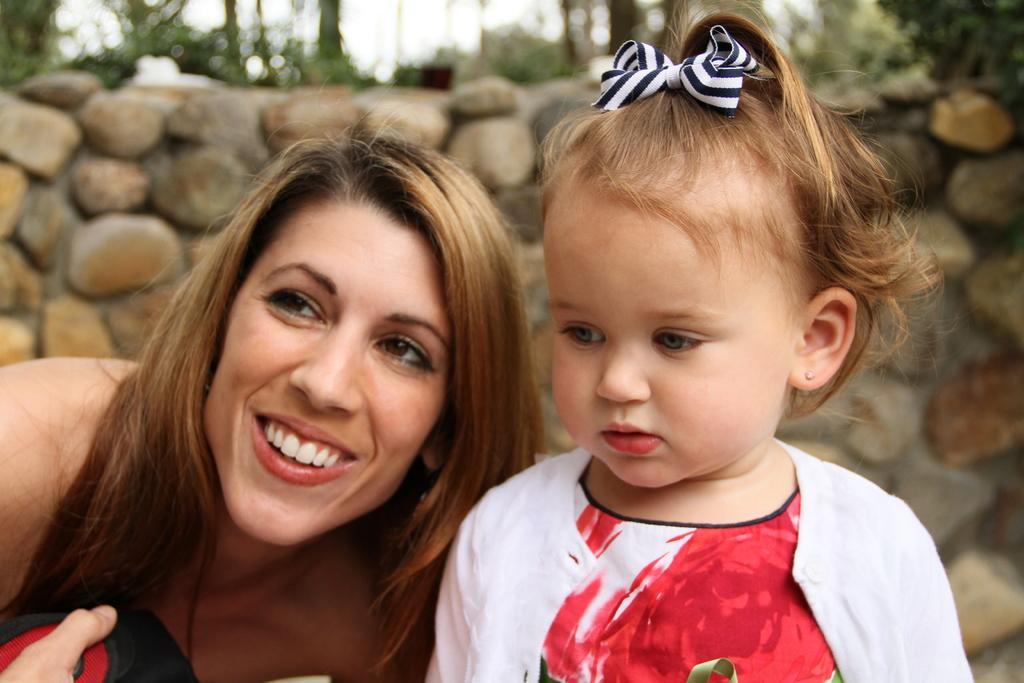Could you give a brief overview of what you see in this image? In this image we can see a woman and a child. On the backside we can see a wall with stones, some plants and the sky. 